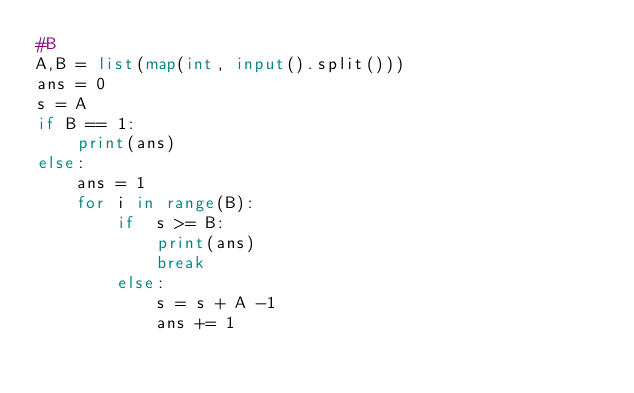<code> <loc_0><loc_0><loc_500><loc_500><_Python_>#B
A,B = list(map(int, input().split()))
ans = 0
s = A
if B == 1:
    print(ans)
else:
    ans = 1
    for i in range(B):
        if  s >= B:
            print(ans)
            break
        else:
            s = s + A -1
            ans += 1</code> 